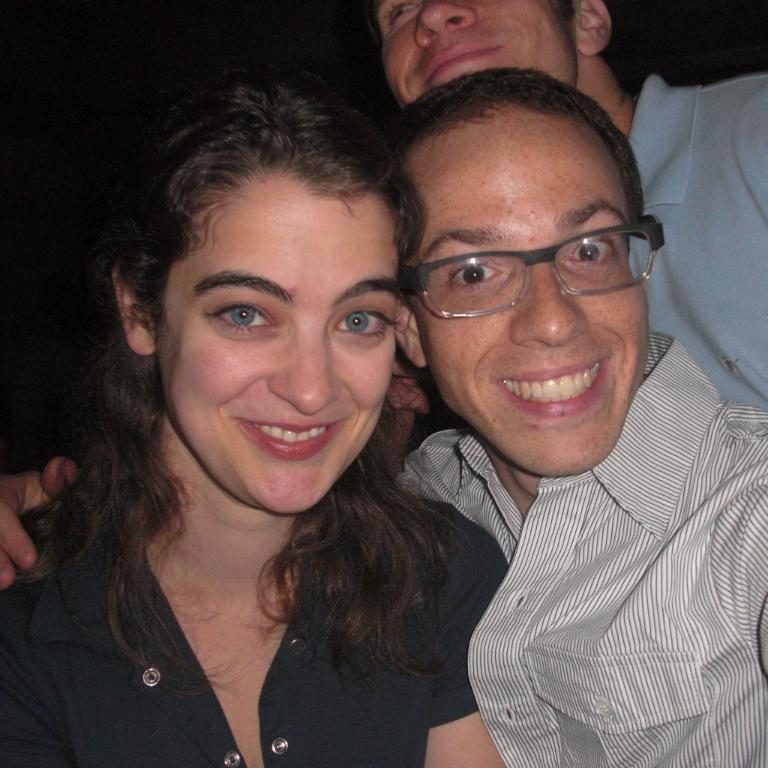How many people are present in the image? There are three people in the image, two men and a woman. What type of suit is the woman wearing in the image? There is no mention of a suit in the image, as it only states that there are two men and a woman present. 